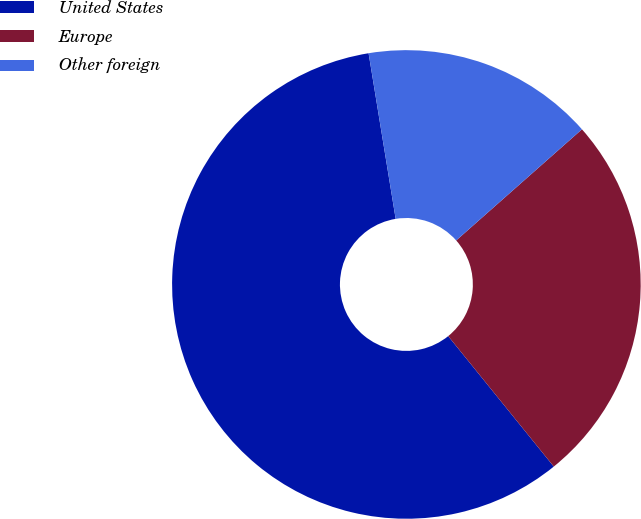Convert chart. <chart><loc_0><loc_0><loc_500><loc_500><pie_chart><fcel>United States<fcel>Europe<fcel>Other foreign<nl><fcel>58.25%<fcel>25.69%<fcel>16.06%<nl></chart> 